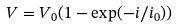<formula> <loc_0><loc_0><loc_500><loc_500>V = V _ { 0 } ( 1 - \exp ( - i / i _ { 0 } ) )</formula> 